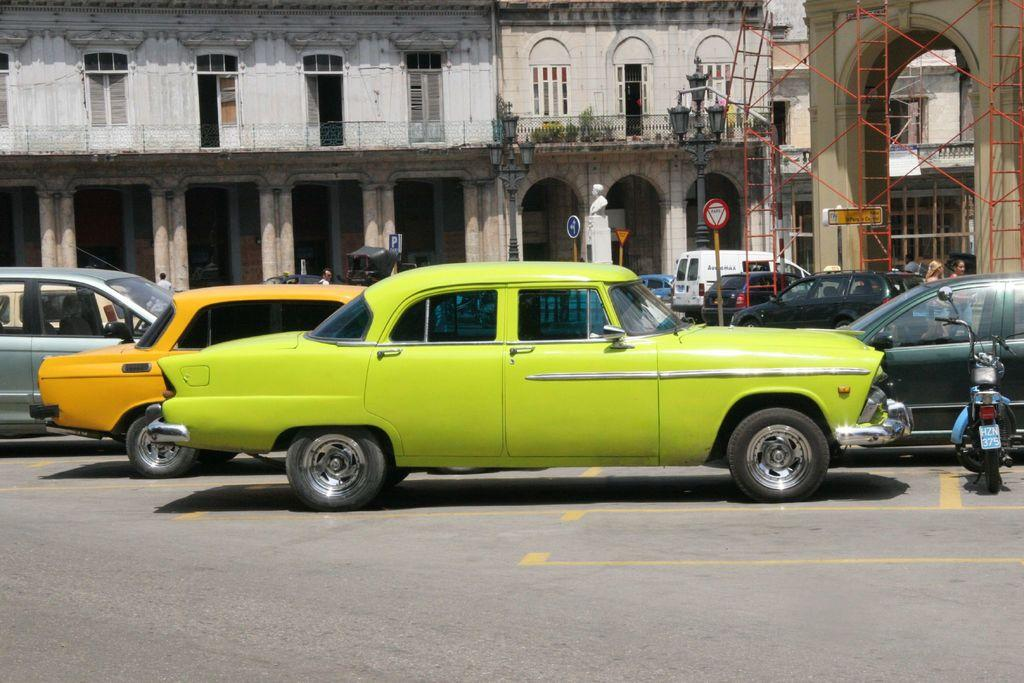<image>
Relay a brief, clear account of the picture shown. A red outlined traffic sign reads Pare in the middle of the street.. 